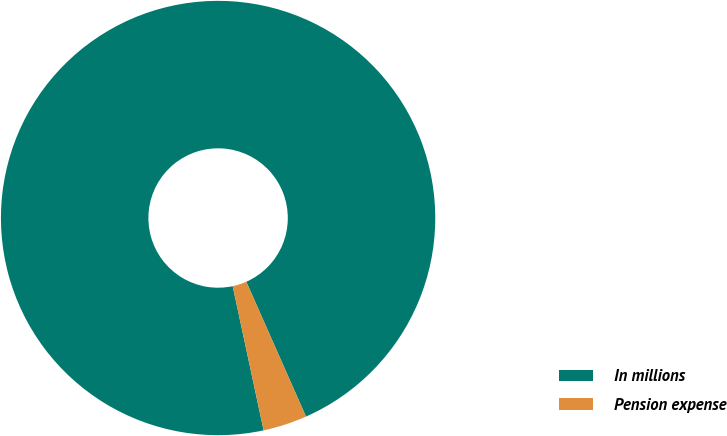Convert chart. <chart><loc_0><loc_0><loc_500><loc_500><pie_chart><fcel>In millions<fcel>Pension expense<nl><fcel>96.73%<fcel>3.27%<nl></chart> 